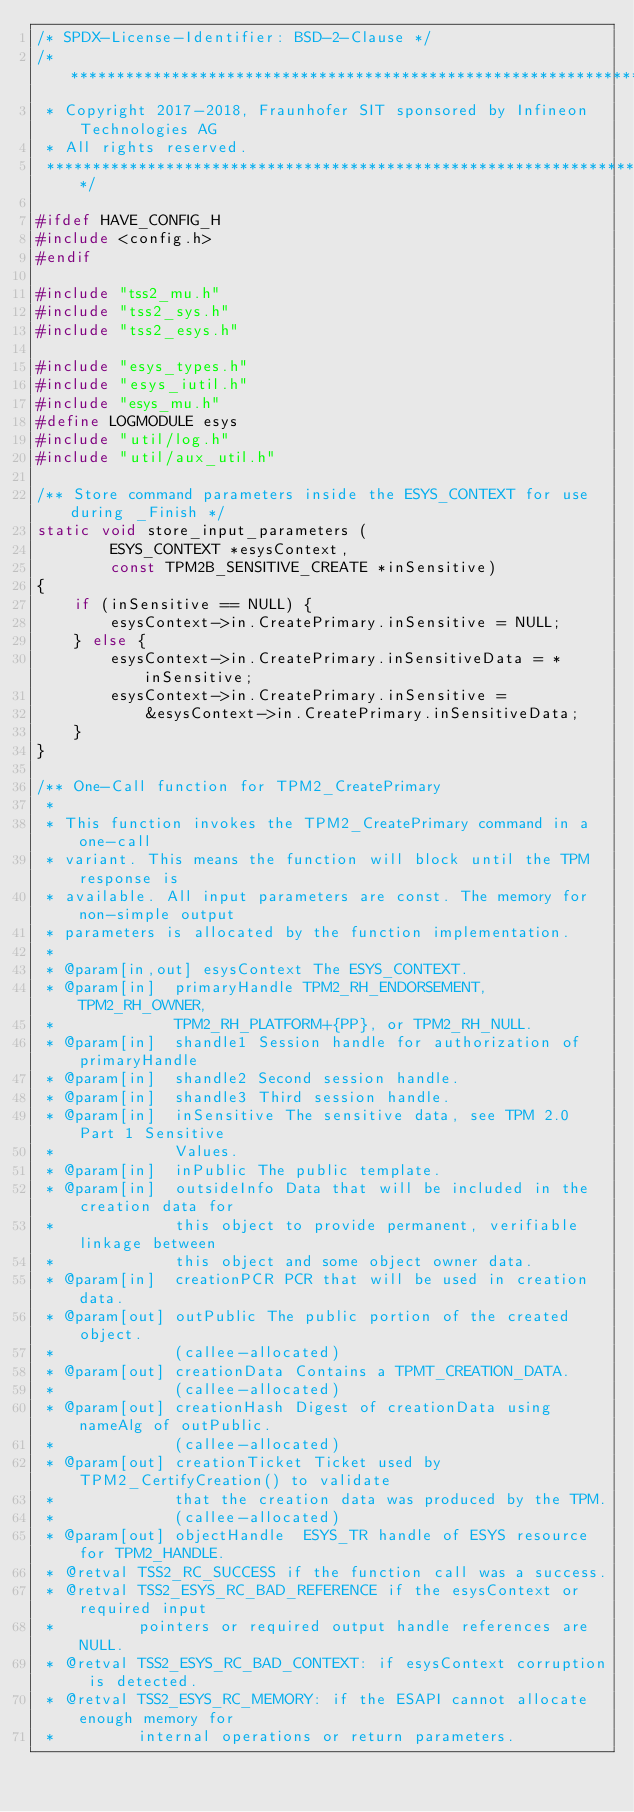Convert code to text. <code><loc_0><loc_0><loc_500><loc_500><_C_>/* SPDX-License-Identifier: BSD-2-Clause */
/*******************************************************************************
 * Copyright 2017-2018, Fraunhofer SIT sponsored by Infineon Technologies AG
 * All rights reserved.
 ******************************************************************************/

#ifdef HAVE_CONFIG_H
#include <config.h>
#endif

#include "tss2_mu.h"
#include "tss2_sys.h"
#include "tss2_esys.h"

#include "esys_types.h"
#include "esys_iutil.h"
#include "esys_mu.h"
#define LOGMODULE esys
#include "util/log.h"
#include "util/aux_util.h"

/** Store command parameters inside the ESYS_CONTEXT for use during _Finish */
static void store_input_parameters (
        ESYS_CONTEXT *esysContext,
        const TPM2B_SENSITIVE_CREATE *inSensitive)
{
    if (inSensitive == NULL) {
        esysContext->in.CreatePrimary.inSensitive = NULL;
    } else {
        esysContext->in.CreatePrimary.inSensitiveData = *inSensitive;
        esysContext->in.CreatePrimary.inSensitive =
            &esysContext->in.CreatePrimary.inSensitiveData;
    }
}

/** One-Call function for TPM2_CreatePrimary
 *
 * This function invokes the TPM2_CreatePrimary command in a one-call
 * variant. This means the function will block until the TPM response is
 * available. All input parameters are const. The memory for non-simple output
 * parameters is allocated by the function implementation.
 *
 * @param[in,out] esysContext The ESYS_CONTEXT.
 * @param[in]  primaryHandle TPM2_RH_ENDORSEMENT, TPM2_RH_OWNER,
 *             TPM2_RH_PLATFORM+{PP}, or TPM2_RH_NULL.
 * @param[in]  shandle1 Session handle for authorization of primaryHandle
 * @param[in]  shandle2 Second session handle.
 * @param[in]  shandle3 Third session handle.
 * @param[in]  inSensitive The sensitive data, see TPM 2.0 Part 1 Sensitive
 *             Values.
 * @param[in]  inPublic The public template.
 * @param[in]  outsideInfo Data that will be included in the creation data for
 *             this object to provide permanent, verifiable linkage between
 *             this object and some object owner data.
 * @param[in]  creationPCR PCR that will be used in creation data.
 * @param[out] outPublic The public portion of the created object.
 *             (callee-allocated)
 * @param[out] creationData Contains a TPMT_CREATION_DATA.
 *             (callee-allocated)
 * @param[out] creationHash Digest of creationData using nameAlg of outPublic.
 *             (callee-allocated)
 * @param[out] creationTicket Ticket used by TPM2_CertifyCreation() to validate
 *             that the creation data was produced by the TPM.
 *             (callee-allocated)
 * @param[out] objectHandle  ESYS_TR handle of ESYS resource for TPM2_HANDLE.
 * @retval TSS2_RC_SUCCESS if the function call was a success.
 * @retval TSS2_ESYS_RC_BAD_REFERENCE if the esysContext or required input
 *         pointers or required output handle references are NULL.
 * @retval TSS2_ESYS_RC_BAD_CONTEXT: if esysContext corruption is detected.
 * @retval TSS2_ESYS_RC_MEMORY: if the ESAPI cannot allocate enough memory for
 *         internal operations or return parameters.</code> 